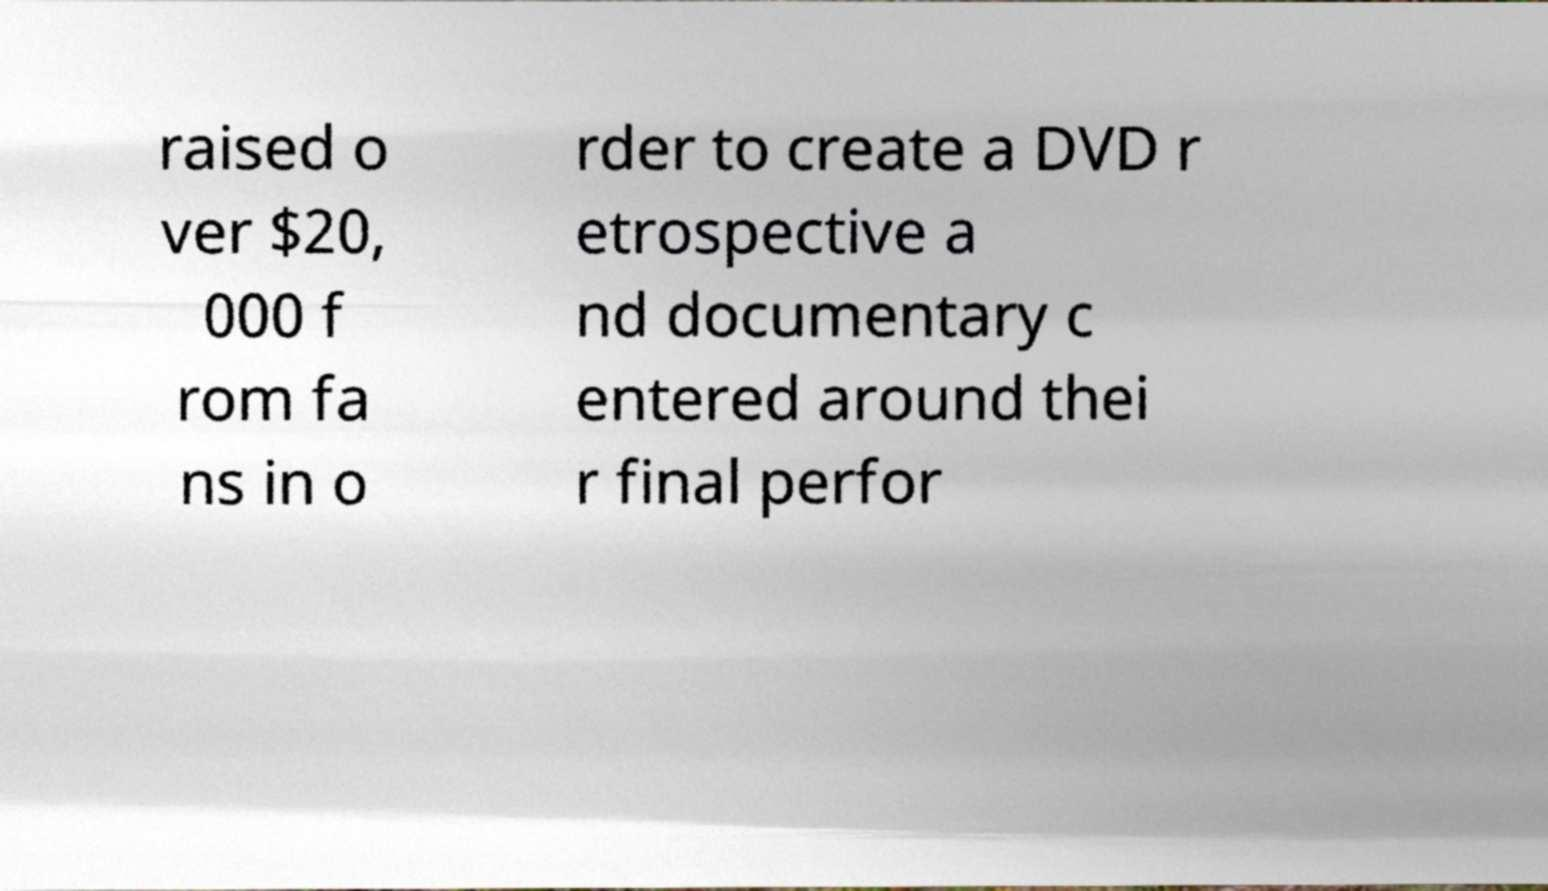Could you extract and type out the text from this image? raised o ver $20, 000 f rom fa ns in o rder to create a DVD r etrospective a nd documentary c entered around thei r final perfor 